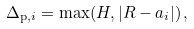Convert formula to latex. <formula><loc_0><loc_0><loc_500><loc_500>\Delta _ { \mathrm p , i } = \max ( H , | R - a _ { i } | ) \, ,</formula> 